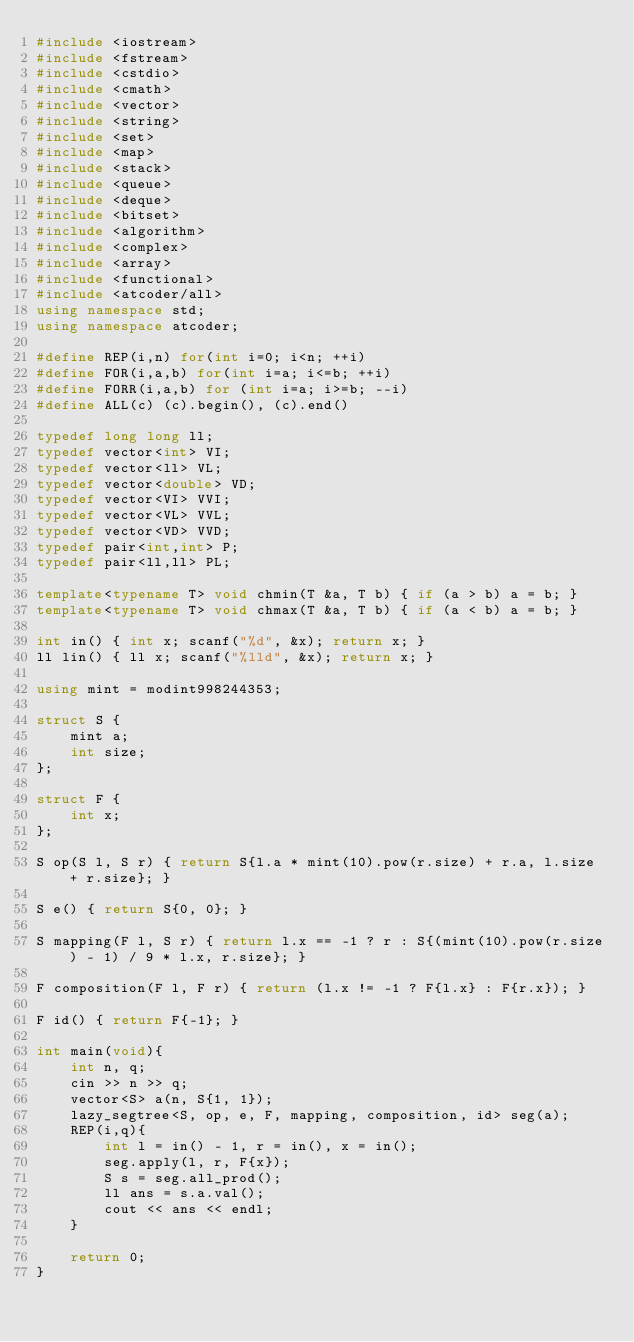<code> <loc_0><loc_0><loc_500><loc_500><_C++_>#include <iostream>
#include <fstream>
#include <cstdio>
#include <cmath>
#include <vector>
#include <string>
#include <set>
#include <map>
#include <stack>
#include <queue>
#include <deque>
#include <bitset>
#include <algorithm>
#include <complex>
#include <array>
#include <functional>
#include <atcoder/all>
using namespace std;
using namespace atcoder;

#define REP(i,n) for(int i=0; i<n; ++i)
#define FOR(i,a,b) for(int i=a; i<=b; ++i)
#define FORR(i,a,b) for (int i=a; i>=b; --i)
#define ALL(c) (c).begin(), (c).end()

typedef long long ll;
typedef vector<int> VI;
typedef vector<ll> VL;
typedef vector<double> VD;
typedef vector<VI> VVI;
typedef vector<VL> VVL;
typedef vector<VD> VVD;
typedef pair<int,int> P;
typedef pair<ll,ll> PL;

template<typename T> void chmin(T &a, T b) { if (a > b) a = b; }
template<typename T> void chmax(T &a, T b) { if (a < b) a = b; }

int in() { int x; scanf("%d", &x); return x; }
ll lin() { ll x; scanf("%lld", &x); return x; }

using mint = modint998244353;

struct S {
    mint a;
    int size;
};

struct F {
    int x;
};

S op(S l, S r) { return S{l.a * mint(10).pow(r.size) + r.a, l.size + r.size}; }

S e() { return S{0, 0}; }

S mapping(F l, S r) { return l.x == -1 ? r : S{(mint(10).pow(r.size) - 1) / 9 * l.x, r.size}; }

F composition(F l, F r) { return (l.x != -1 ? F{l.x} : F{r.x}); }

F id() { return F{-1}; }

int main(void){
    int n, q;
    cin >> n >> q;
    vector<S> a(n, S{1, 1});
    lazy_segtree<S, op, e, F, mapping, composition, id> seg(a);
    REP(i,q){
        int l = in() - 1, r = in(), x = in();
        seg.apply(l, r, F{x});
        S s = seg.all_prod();
        ll ans = s.a.val();
        cout << ans << endl;
    }

    return 0;
}
</code> 